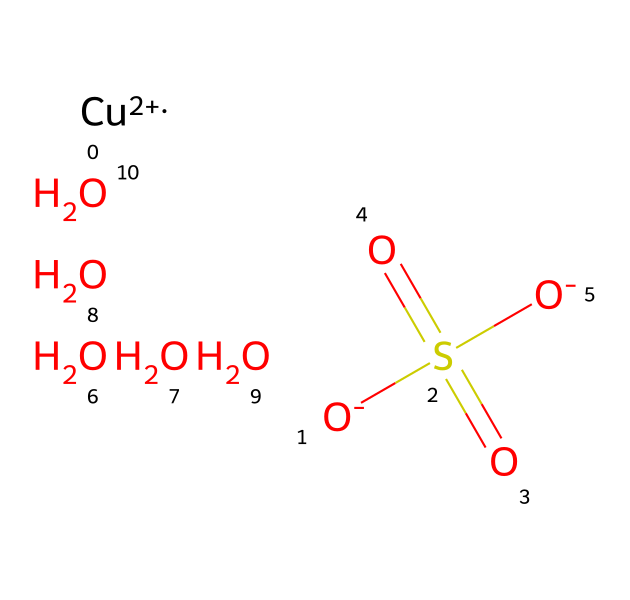What is the central metal ion in this compound? The SMILES representation shows "[Cu+2]", indicating that copper is the central metal ion.
Answer: copper How many sulfate groups are present in the structure? The structure includes "S(=O)(=O)", which represents one sulfate group with sulfur bonded to four oxygen atoms.
Answer: one What is the oxidation state of copper in this compound? The notation "[Cu+2]" indicates that copper has a +2 oxidation state, which is typical for copper salts.
Answer: +2 How many oxygen atoms are bonded to sulfur in this chemical? In the structure, the "S(=O)(=O)[O-]" component shows that sulfur is bonded to four oxygen atoms: two double-bonded (as shown by "=O") and two single-bonded (as shown by "[O-]").
Answer: four What type of solid is copper sulfate most commonly classified as? Copper sulfate is generally classified as an ionic solid due to the ionic bonds between copper ions and sulfate ions.
Answer: ionic Are there any neutral molecules indicated in this structure? The presence of "O.O.O.O" indicates several neutral oxygen molecules connected in the structure, representing additional components.
Answer: yes 